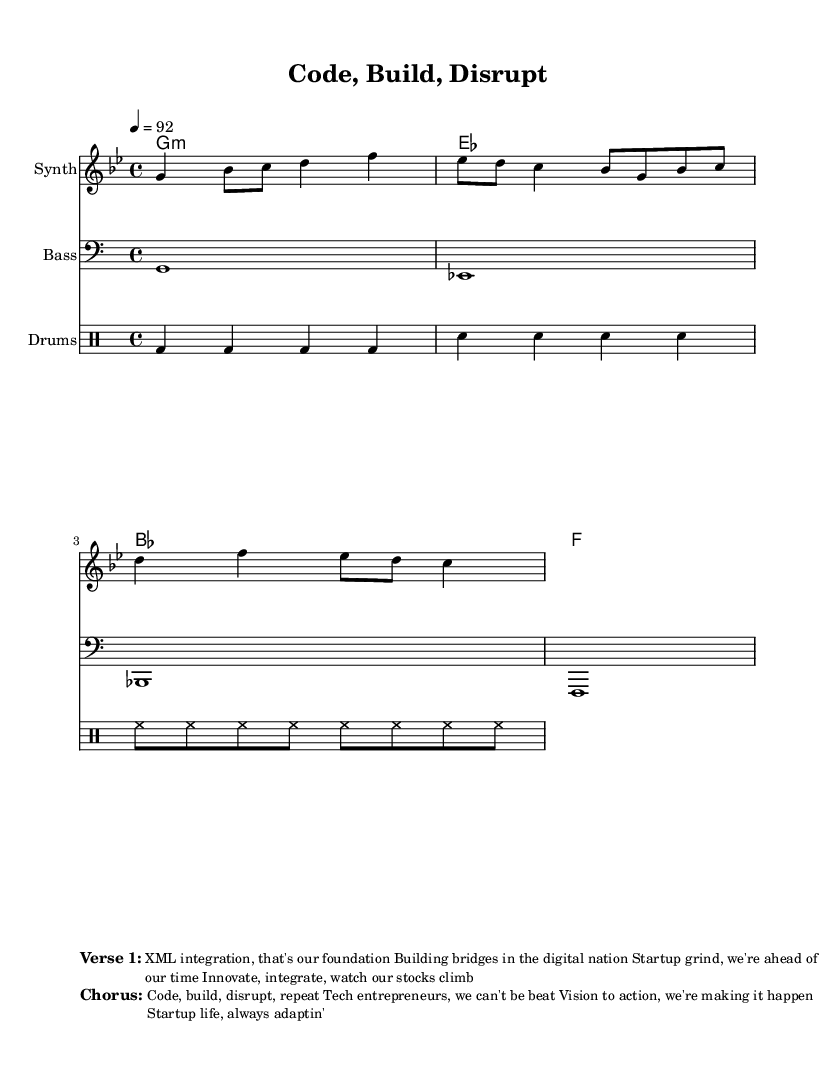What is the key signature of this music? The key signature is G minor, which has two flats: B flat and E flat. This can be identified by the presence of the key signature at the start of the staff that shows these flats.
Answer: G minor What is the time signature of this music? The time signature is 4/4, indicated right after the key signature. This means there are four beats in each measure and the quarter note gets one beat.
Answer: 4/4 What is the tempo marking for this piece? The tempo marking is 92 beats per minute, which is indicated in the global section of the score. This provides the performer with the speed at which to play the piece.
Answer: 92 How many measures are in the melody section? There are three measures in the melody section, which can be counted based on the number of bar lines present in the melody.
Answer: Three What is the primary theme expressed in the lyrics? The primary theme expressed in the lyrics revolves around XML integration and entrepreneurship, emphasizing innovation, integration, and success in the startup ecosystem. This is derived from analyzing the verses provided in the markup section of the sheet music.
Answer: Entrepreneurship What type of musical instrument is used for the melody part? The melody part is played on a Synth, as indicated in the staff name on the score. This suggests a modern electronic sound typical in Hip Hop music.
Answer: Synth What is the type of the drum part shown in the sheet music? The drum part is played using a standard drum set with kick drum, snare, and hi-hat, indicated in the drum staff using the appropriate notation for each drum sound.
Answer: Drum set 